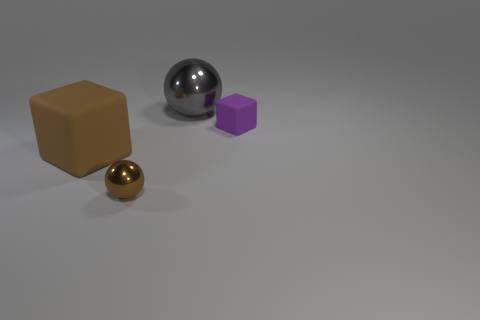What number of large balls are to the right of the small shiny sphere?
Ensure brevity in your answer.  1. The brown block is what size?
Offer a terse response. Large. What is the color of the metal ball that is the same size as the brown cube?
Give a very brief answer. Gray. Is there a block that has the same color as the tiny metal sphere?
Make the answer very short. Yes. What is the purple block made of?
Keep it short and to the point. Rubber. What number of gray shiny things are there?
Your response must be concise. 1. There is a metallic ball that is in front of the brown matte object; does it have the same color as the rubber thing left of the gray metallic ball?
Ensure brevity in your answer.  Yes. What is the size of the matte object that is the same color as the tiny metallic sphere?
Your response must be concise. Large. How many other objects are there of the same size as the brown metal sphere?
Give a very brief answer. 1. The block behind the large brown cube is what color?
Keep it short and to the point. Purple. 